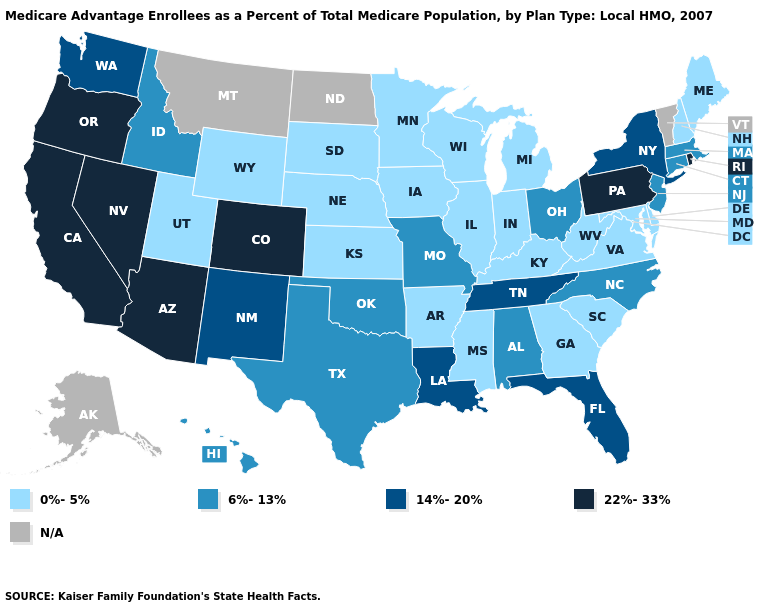Among the states that border Minnesota , which have the lowest value?
Give a very brief answer. Iowa, South Dakota, Wisconsin. Does the map have missing data?
Write a very short answer. Yes. Which states hav the highest value in the MidWest?
Keep it brief. Missouri, Ohio. Which states have the lowest value in the West?
Short answer required. Utah, Wyoming. What is the lowest value in the South?
Write a very short answer. 0%-5%. Among the states that border West Virginia , which have the highest value?
Keep it brief. Pennsylvania. Name the states that have a value in the range N/A?
Write a very short answer. Alaska, Montana, North Dakota, Vermont. Among the states that border Arkansas , which have the highest value?
Concise answer only. Louisiana, Tennessee. Which states hav the highest value in the South?
Be succinct. Florida, Louisiana, Tennessee. What is the lowest value in the MidWest?
Keep it brief. 0%-5%. What is the value of Florida?
Give a very brief answer. 14%-20%. What is the value of Tennessee?
Quick response, please. 14%-20%. Which states hav the highest value in the West?
Short answer required. Arizona, California, Colorado, Nevada, Oregon. What is the value of Mississippi?
Be succinct. 0%-5%. 